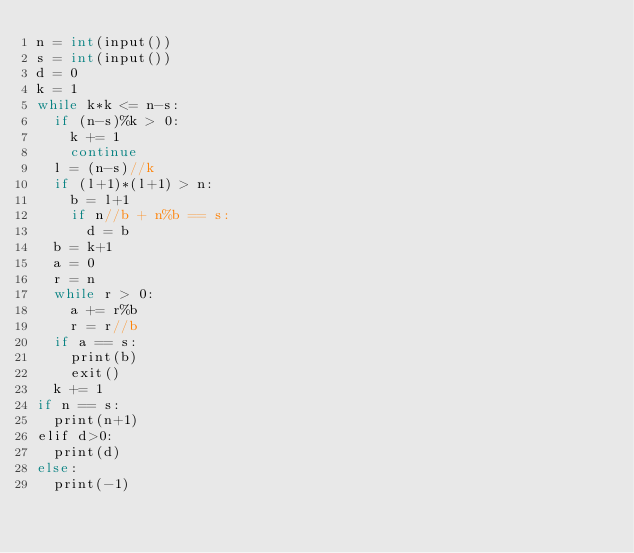Convert code to text. <code><loc_0><loc_0><loc_500><loc_500><_Java_>n = int(input())
s = int(input())
d = 0
k = 1
while k*k <= n-s:
  if (n-s)%k > 0:
    k += 1
    continue
  l = (n-s)//k
  if (l+1)*(l+1) > n:
    b = l+1
    if n//b + n%b == s:
      d = b
  b = k+1
  a = 0
  r = n
  while r > 0:
    a += r%b
    r = r//b
  if a == s:
    print(b)
    exit()
  k += 1
if n == s:
  print(n+1)
elif d>0:
  print(d)
else:
  print(-1)</code> 